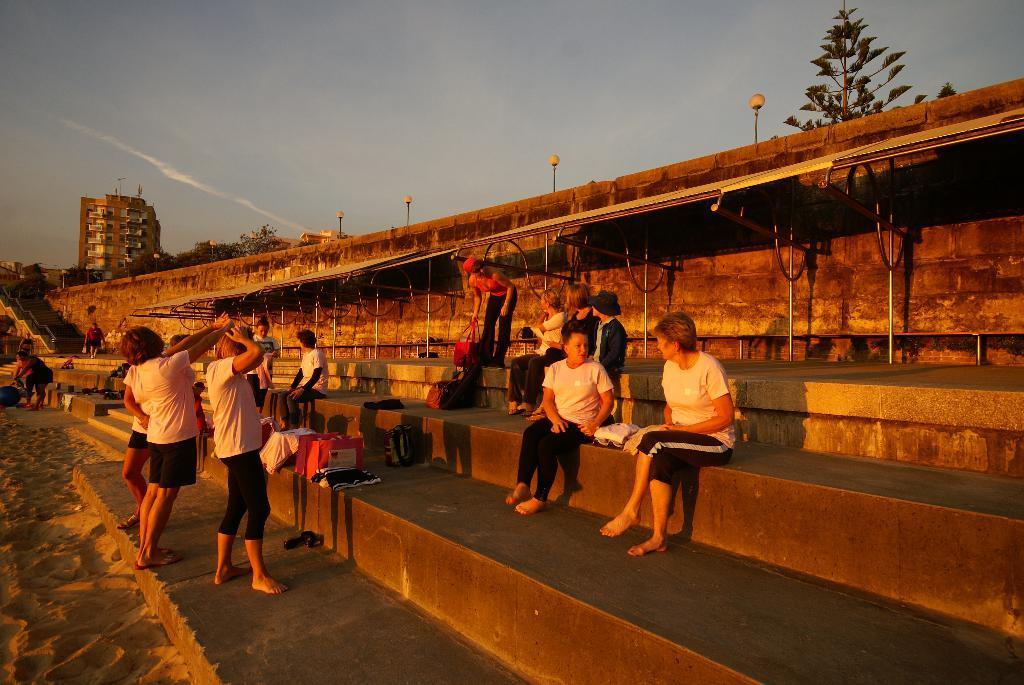In one or two sentences, can you explain what this image depicts? In the center of the image there is a staircase on which there are people. In the background of the image there is sky. There is a building. To the right side of the image there is a tree. At the bottom of the image there is sand. 